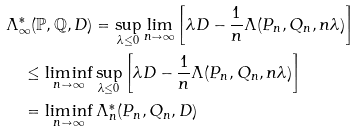<formula> <loc_0><loc_0><loc_500><loc_500>& \Lambda _ { \infty } ^ { * } ( \mathbb { P } , \mathbb { Q } , D ) = \sup _ { \lambda \leq 0 } \lim _ { n \to \infty } \left [ \lambda D - \frac { 1 } { n } \Lambda ( P _ { n } , Q _ { n } , n \lambda ) \right ] \\ & \quad \leq \liminf _ { n \to \infty } \sup _ { \lambda \leq 0 } \left [ \lambda D - \frac { 1 } { n } \Lambda ( P _ { n } , Q _ { n } , n \lambda ) \right ] \\ & \quad = \liminf _ { n \to \infty } \Lambda _ { n } ^ { * } ( P _ { n } , Q _ { n } , D )</formula> 